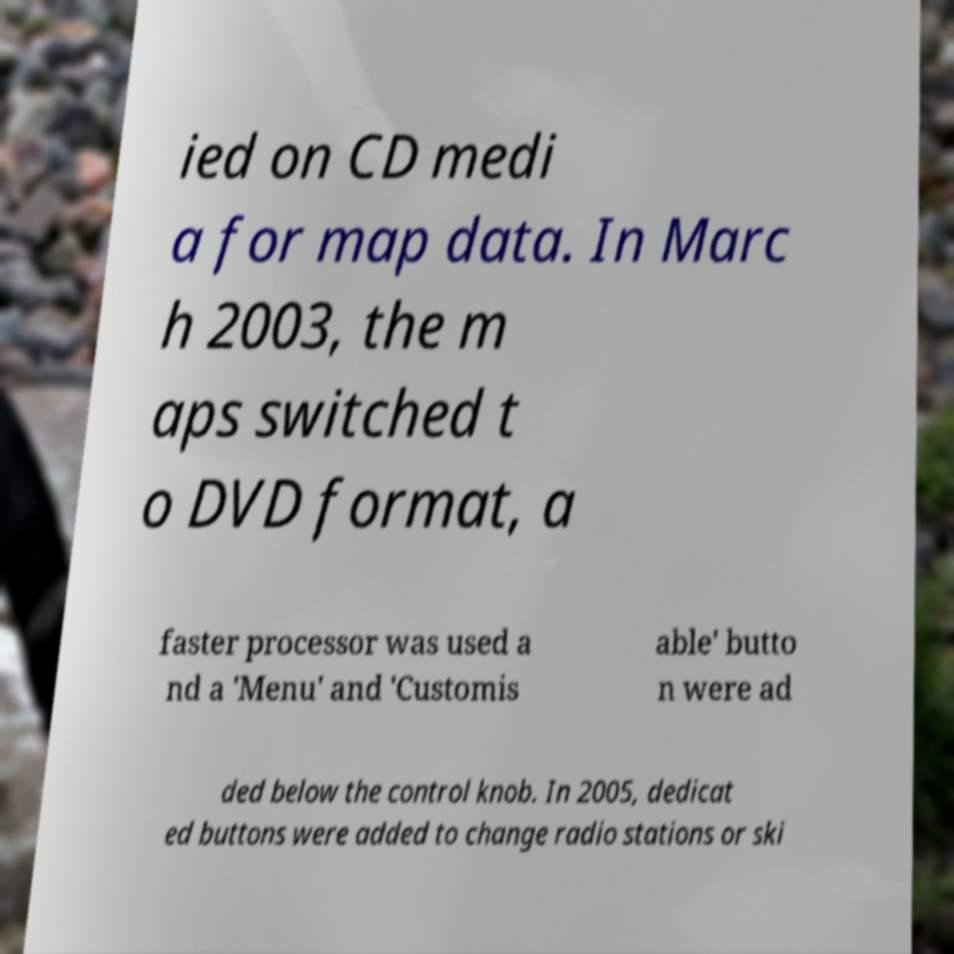For documentation purposes, I need the text within this image transcribed. Could you provide that? ied on CD medi a for map data. In Marc h 2003, the m aps switched t o DVD format, a faster processor was used a nd a 'Menu' and 'Customis able' butto n were ad ded below the control knob. In 2005, dedicat ed buttons were added to change radio stations or ski 